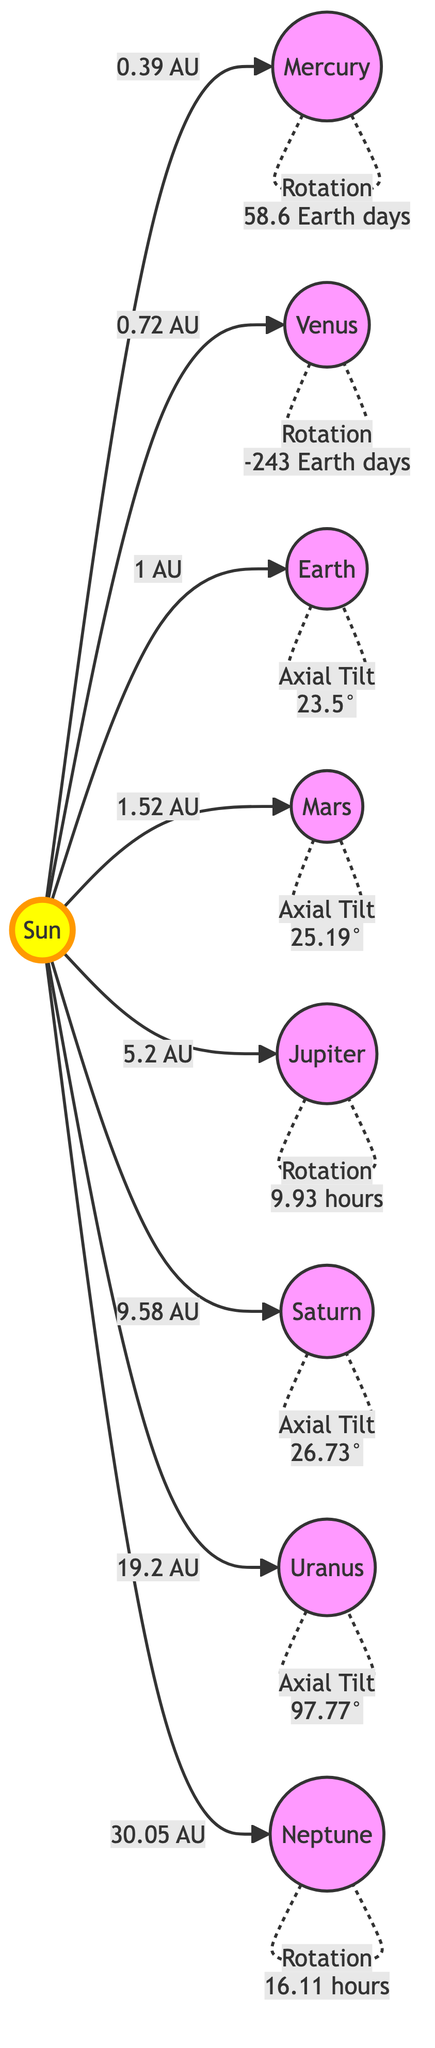What is the distance of Mars from the Sun? The diagram shows that Mars is 1.52 AU away from the Sun, indicated directly by the arrow connecting Mars to the Sun with the label "1.52 AU."
Answer: 1.52 AU Which planet has the highest axial tilt? The diagram indicates that Uranus has an axial tilt of 97.77°, which is the highest value shown in the annotations next to the planets.
Answer: 97.77° How many planets are shown in the diagram? By counting the nodes labeled as planets in the diagram, there are a total of eight distinct planet nodes representing the planets in our solar system.
Answer: 8 What is the rotation period of Venus? According to the diagram, Venus has a rotation period of -243 Earth days, which is specified in the annotation next to the planet.
Answer: -243 Earth days Which planet is closest to the Sun? The diagram defines Mercury as the closest planet, as it is directly linked to the Sun with a short distance label of 0.39 AU, indicating proximity.
Answer: Mercury Which planet has an axial tilt closest to Earth's axial tilt? By comparing the axial tilt values, we see Earth has an axial tilt of 23.5° and Mars has an axial tilt of 25.19°. Mars' tilt is closest to that of Earth, as it is only 1.69° greater.
Answer: Mars How does the rotation period of Jupiter compare to that of Neptune? The diagram shows that Jupiter has a rotation period of 9.93 hours and Neptune has a rotation period of 16.11 hours. Since 9.93 hours is less than 16.11 hours, Jupiter rotates faster than Neptune.
Answer: Jupiter What scale is used to indicate distances in the diagram? The distances from the Sun to each planet are expressed in astronomical units (AU), which is the scale used throughout the diagram for measuring distances in the solar system.
Answer: AU Which planet takes the longest to complete one rotation? The annotation next to Venus specifies its rotation period as -243 Earth days, indicating it takes the longest of all listed planets to complete a full rotation.
Answer: Venus 